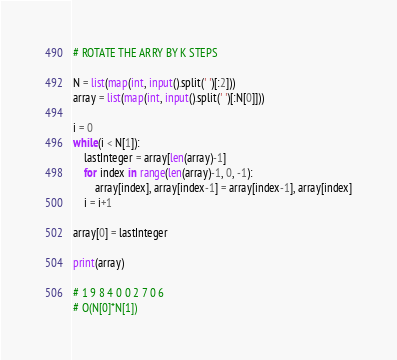<code> <loc_0><loc_0><loc_500><loc_500><_Python_># ROTATE THE ARRY BY K STEPS

N = list(map(int, input().split(' ')[:2]))
array = list(map(int, input().split(' ')[:N[0]]))

i = 0
while(i < N[1]):
    lastInteger = array[len(array)-1]
    for index in range(len(array)-1, 0, -1):
        array[index], array[index-1] = array[index-1], array[index]
    i = i+1

array[0] = lastInteger

print(array)

# 1 9 8 4 0 0 2 7 0 6
# O(N[0]*N[1])
</code> 